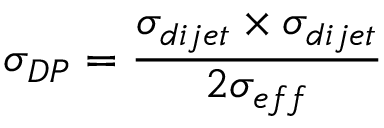Convert formula to latex. <formula><loc_0><loc_0><loc_500><loc_500>\sigma _ { D P } = { \frac { \sigma _ { d i j e t } \times \sigma _ { d i j e t } } { 2 \sigma _ { e f f } } }</formula> 